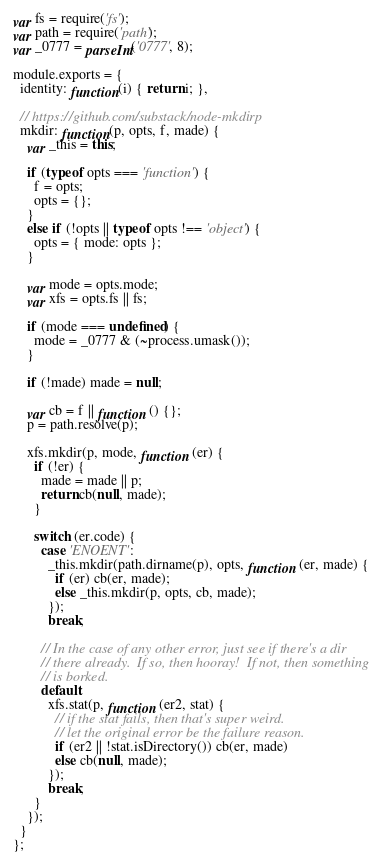<code> <loc_0><loc_0><loc_500><loc_500><_JavaScript_>var fs = require('fs');
var path = require('path');
var _0777 = parseInt('0777', 8);

module.exports = {
  identity: function(i) { return i; },

  // https://github.com/substack/node-mkdirp
  mkdir: function(p, opts, f, made) {
    var _this = this;

    if (typeof opts === 'function') {
      f = opts;
      opts = {};
    }
    else if (!opts || typeof opts !== 'object') {
      opts = { mode: opts };
    }

    var mode = opts.mode;
    var xfs = opts.fs || fs;

    if (mode === undefined) {
      mode = _0777 & (~process.umask());
    }

    if (!made) made = null;

    var cb = f || function () {};
    p = path.resolve(p);

    xfs.mkdir(p, mode, function (er) {
      if (!er) {
        made = made || p;
        return cb(null, made);
      }

      switch (er.code) {
        case 'ENOENT':
          _this.mkdir(path.dirname(p), opts, function (er, made) {
            if (er) cb(er, made);
            else _this.mkdir(p, opts, cb, made);
          });
          break;

        // In the case of any other error, just see if there's a dir
        // there already.  If so, then hooray!  If not, then something
        // is borked.
        default:
          xfs.stat(p, function (er2, stat) {
            // if the stat fails, then that's super weird.
            // let the original error be the failure reason.
            if (er2 || !stat.isDirectory()) cb(er, made)
            else cb(null, made);
          });
          break;
      }
    });
  }
};
</code> 